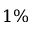Convert formula to latex. <formula><loc_0><loc_0><loc_500><loc_500>1 \%</formula> 